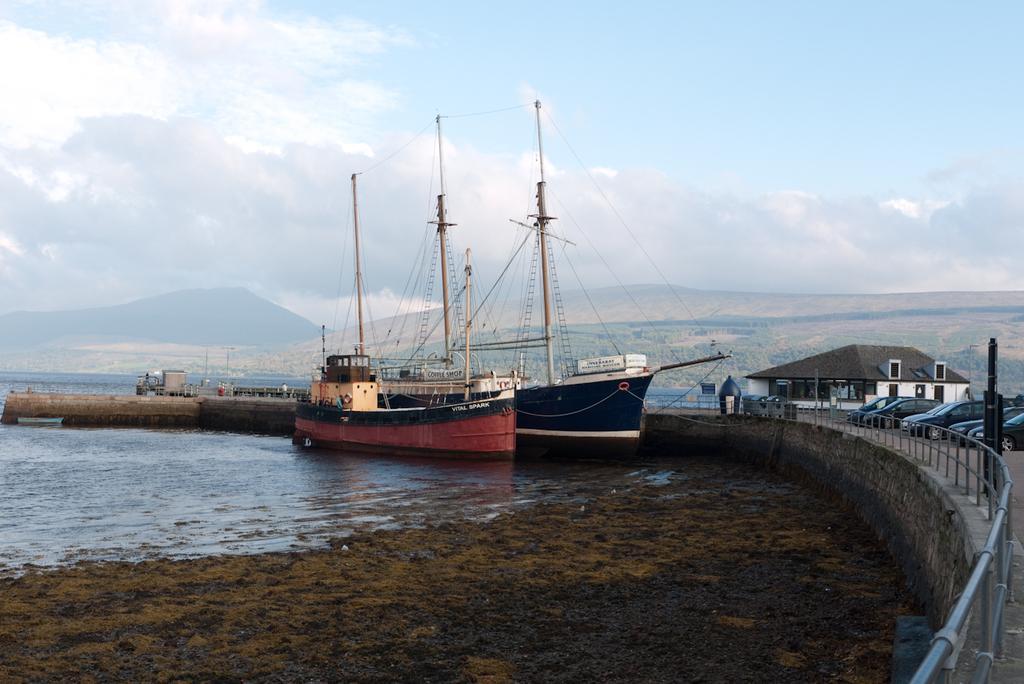Could you give a brief overview of what you see in this image? In this image there are two ships in the water, mud, few vehicles, boards, a person on the bridge, there are few poles, a building, few mountains and some clouds in the sky. 